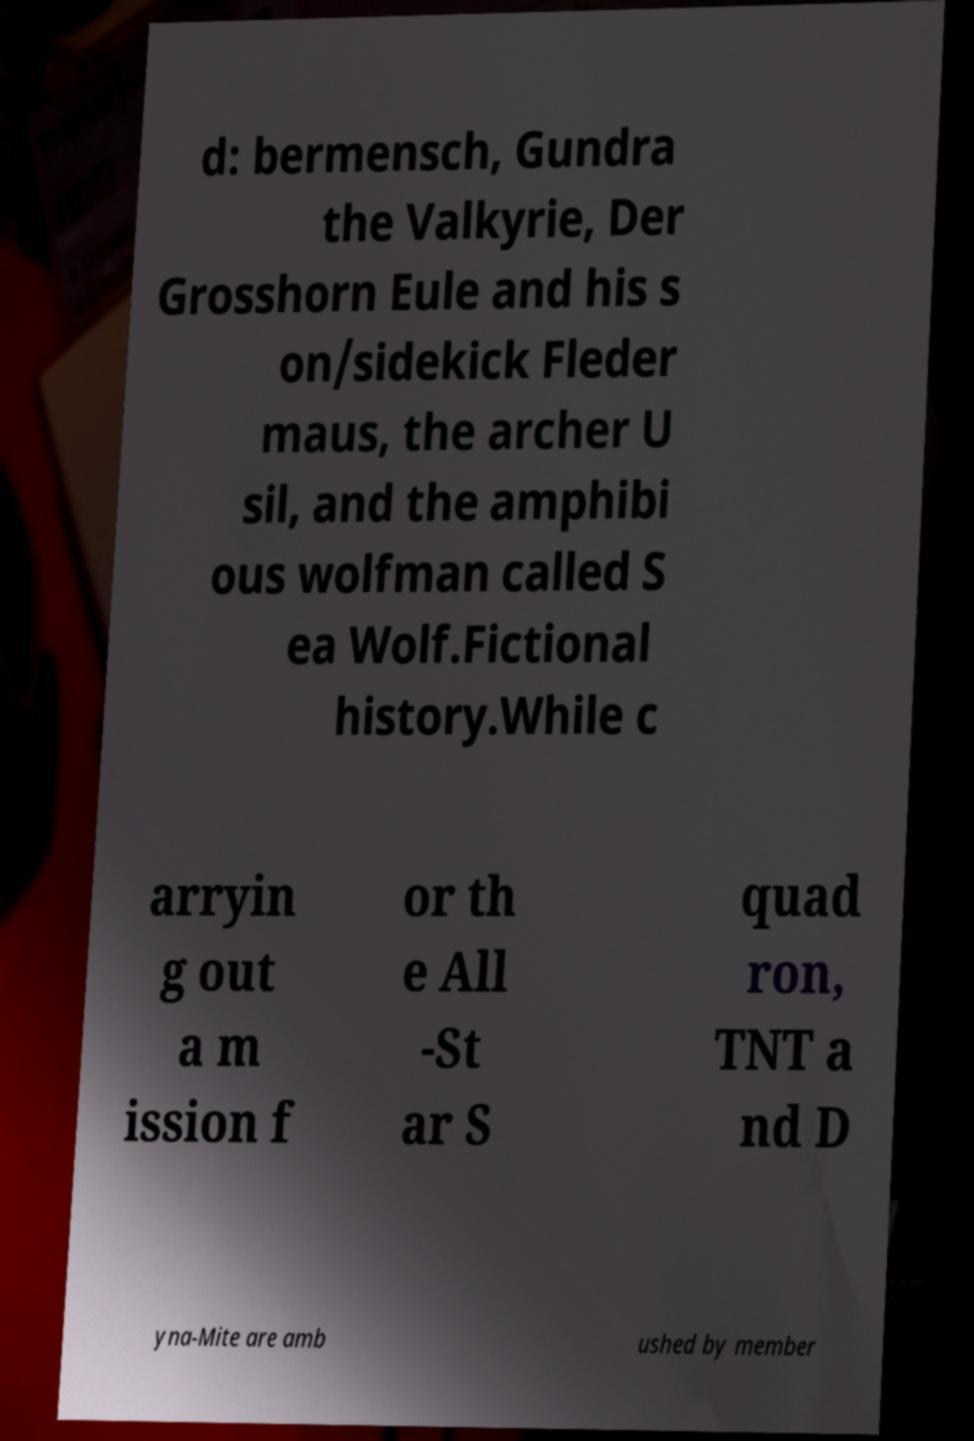I need the written content from this picture converted into text. Can you do that? d: bermensch, Gundra the Valkyrie, Der Grosshorn Eule and his s on/sidekick Fleder maus, the archer U sil, and the amphibi ous wolfman called S ea Wolf.Fictional history.While c arryin g out a m ission f or th e All -St ar S quad ron, TNT a nd D yna-Mite are amb ushed by member 